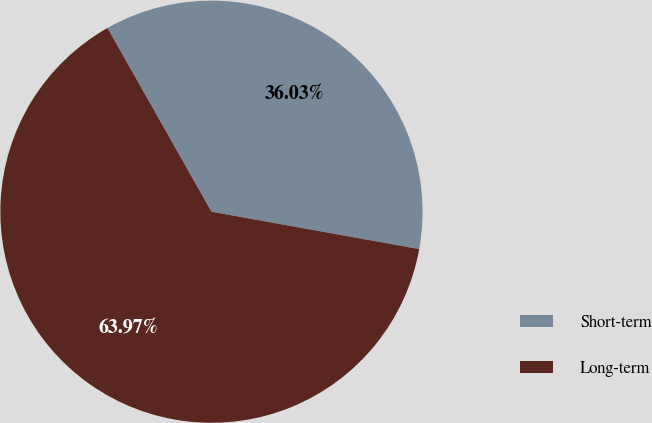Convert chart. <chart><loc_0><loc_0><loc_500><loc_500><pie_chart><fcel>Short-term<fcel>Long-term<nl><fcel>36.03%<fcel>63.97%<nl></chart> 